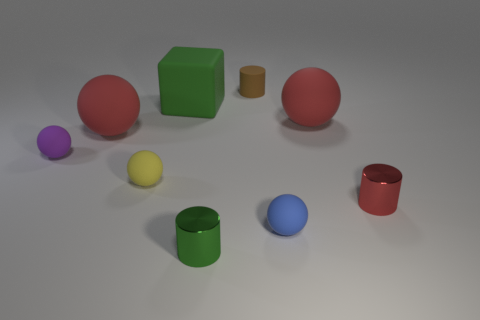Subtract 1 balls. How many balls are left? 4 Subtract all small purple spheres. How many spheres are left? 4 Subtract all yellow balls. How many balls are left? 4 Subtract all cyan balls. Subtract all red cylinders. How many balls are left? 5 Subtract all balls. How many objects are left? 4 Subtract all matte balls. Subtract all tiny yellow balls. How many objects are left? 3 Add 8 tiny red metal cylinders. How many tiny red metal cylinders are left? 9 Add 9 purple spheres. How many purple spheres exist? 10 Subtract 0 blue cylinders. How many objects are left? 9 